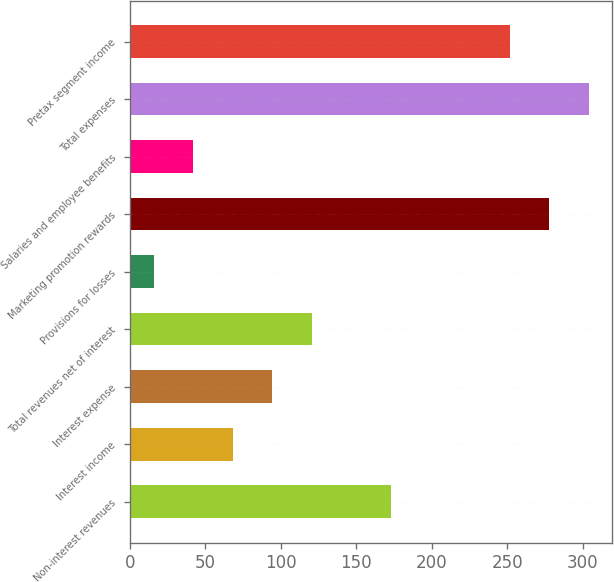<chart> <loc_0><loc_0><loc_500><loc_500><bar_chart><fcel>Non-interest revenues<fcel>Interest income<fcel>Interest expense<fcel>Total revenues net of interest<fcel>Provisions for losses<fcel>Marketing promotion rewards<fcel>Salaries and employee benefits<fcel>Total expenses<fcel>Pretax segment income<nl><fcel>173.2<fcel>68.4<fcel>94.6<fcel>120.8<fcel>16<fcel>278<fcel>42.2<fcel>304.2<fcel>251.8<nl></chart> 